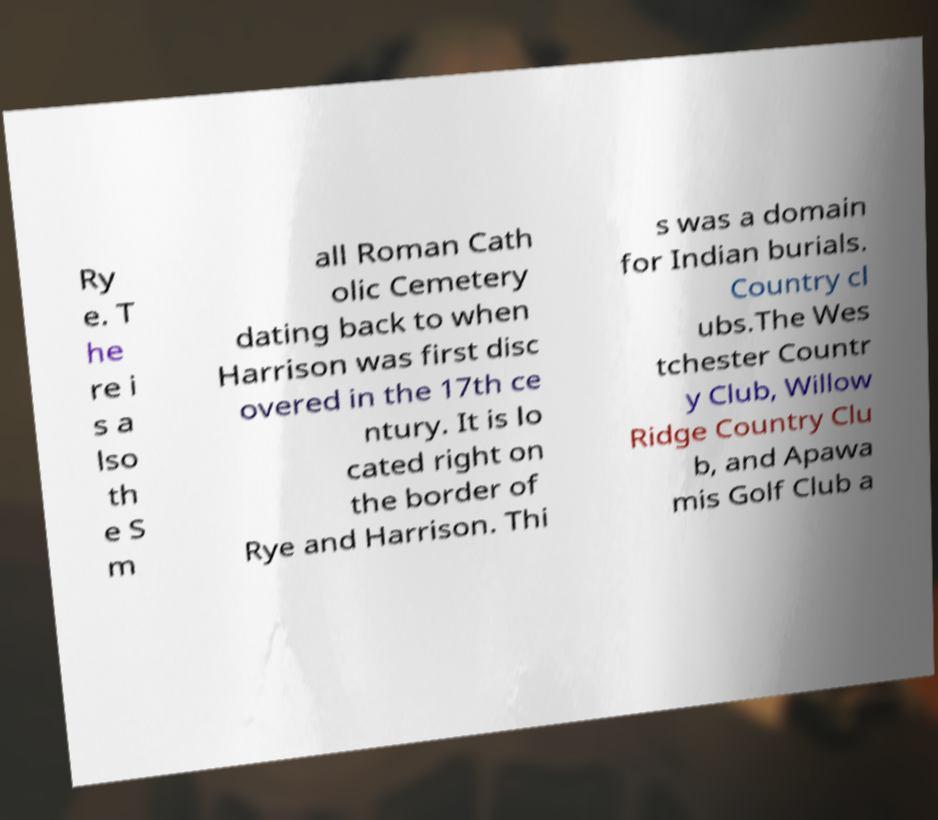Can you accurately transcribe the text from the provided image for me? Ry e. T he re i s a lso th e S m all Roman Cath olic Cemetery dating back to when Harrison was first disc overed in the 17th ce ntury. It is lo cated right on the border of Rye and Harrison. Thi s was a domain for Indian burials. Country cl ubs.The Wes tchester Countr y Club, Willow Ridge Country Clu b, and Apawa mis Golf Club a 